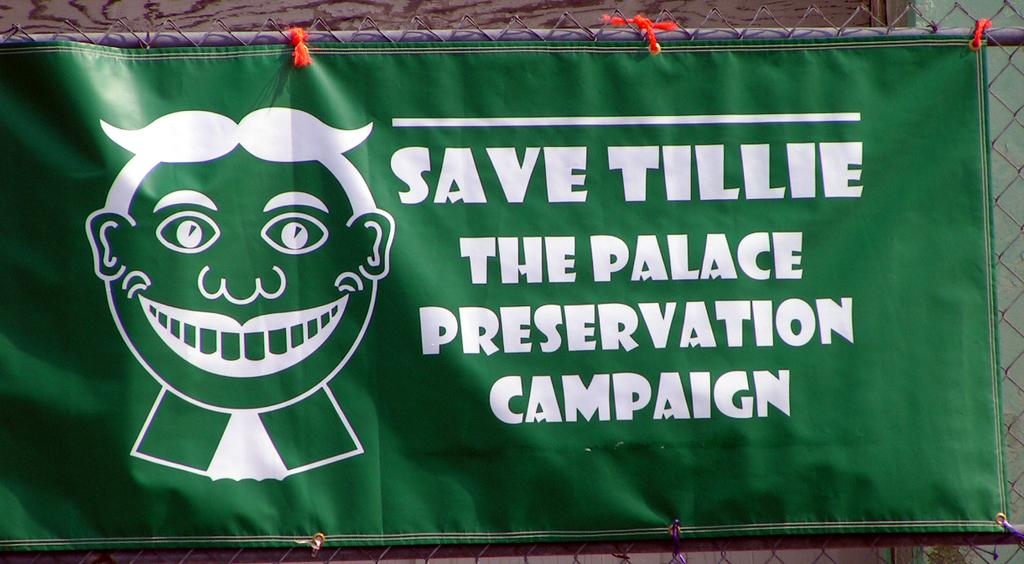<image>
Summarize the visual content of the image. A banner on a chain link fence that says Save Tillie. 